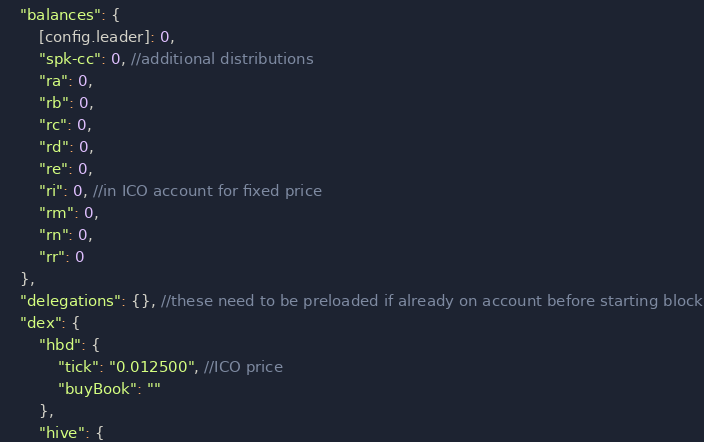Convert code to text. <code><loc_0><loc_0><loc_500><loc_500><_JavaScript_>    "balances": {
        [config.leader]: 0,
        "spk-cc": 0, //additional distributions
        "ra": 0,
        "rb": 0,
        "rc": 0,
        "rd": 0,
        "re": 0,
        "ri": 0, //in ICO account for fixed price
        "rm": 0,
        "rn": 0,
        "rr": 0
    },
    "delegations": {}, //these need to be preloaded if already on account before starting block
    "dex": {
        "hbd": {
            "tick": "0.012500", //ICO price
            "buyBook": ""
        },
        "hive": {</code> 